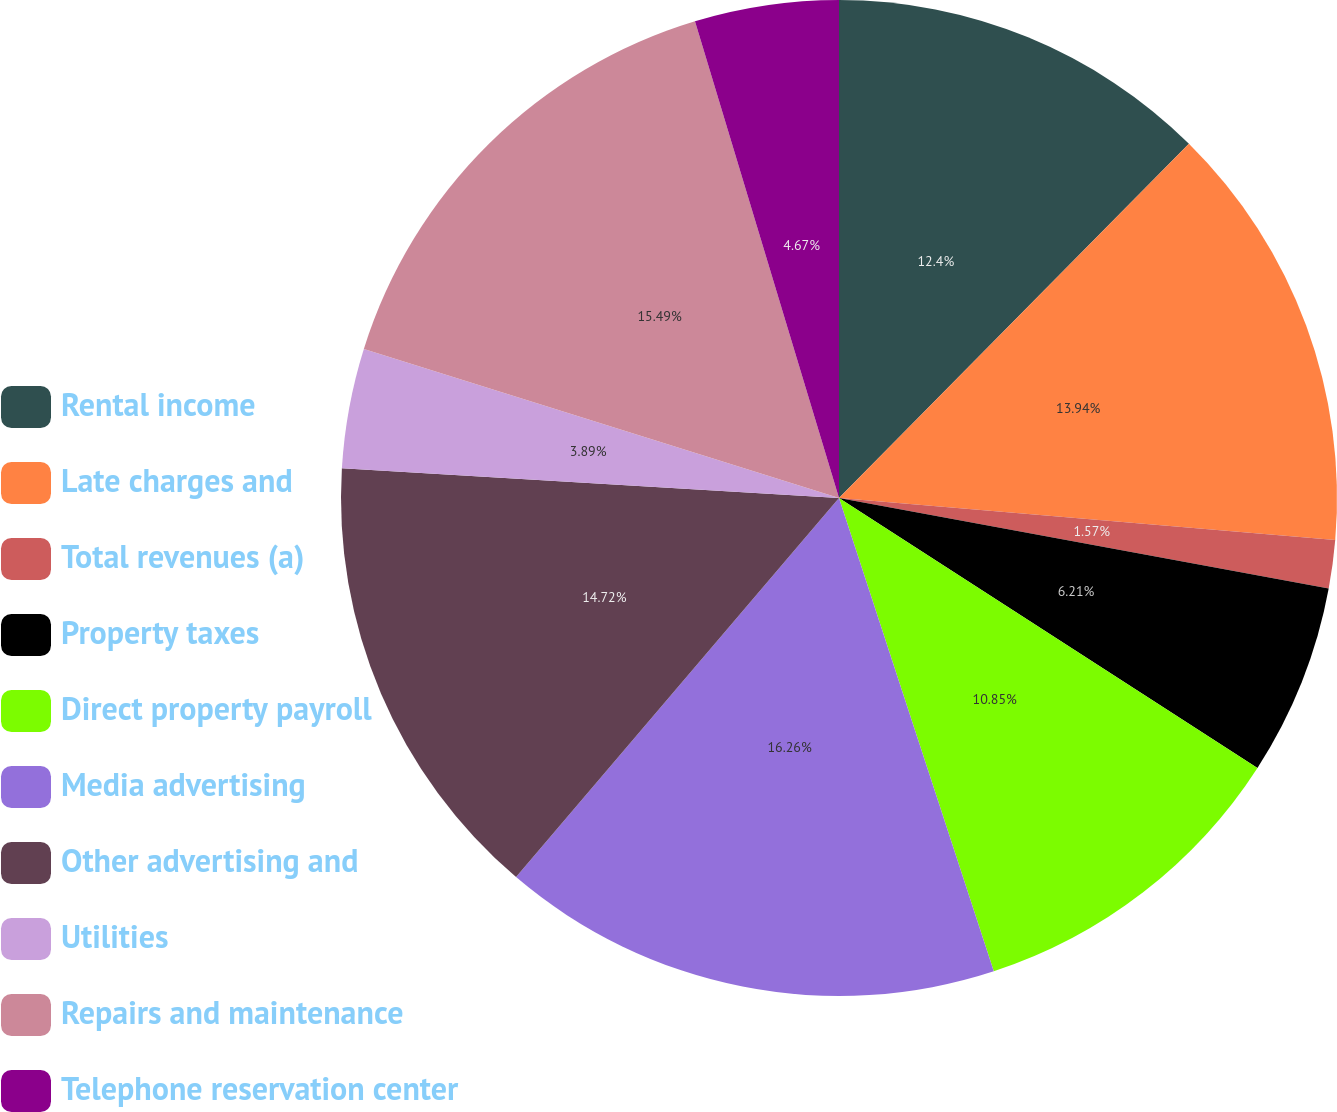<chart> <loc_0><loc_0><loc_500><loc_500><pie_chart><fcel>Rental income<fcel>Late charges and<fcel>Total revenues (a)<fcel>Property taxes<fcel>Direct property payroll<fcel>Media advertising<fcel>Other advertising and<fcel>Utilities<fcel>Repairs and maintenance<fcel>Telephone reservation center<nl><fcel>12.4%<fcel>13.94%<fcel>1.57%<fcel>6.21%<fcel>10.85%<fcel>16.26%<fcel>14.72%<fcel>3.89%<fcel>15.49%<fcel>4.67%<nl></chart> 